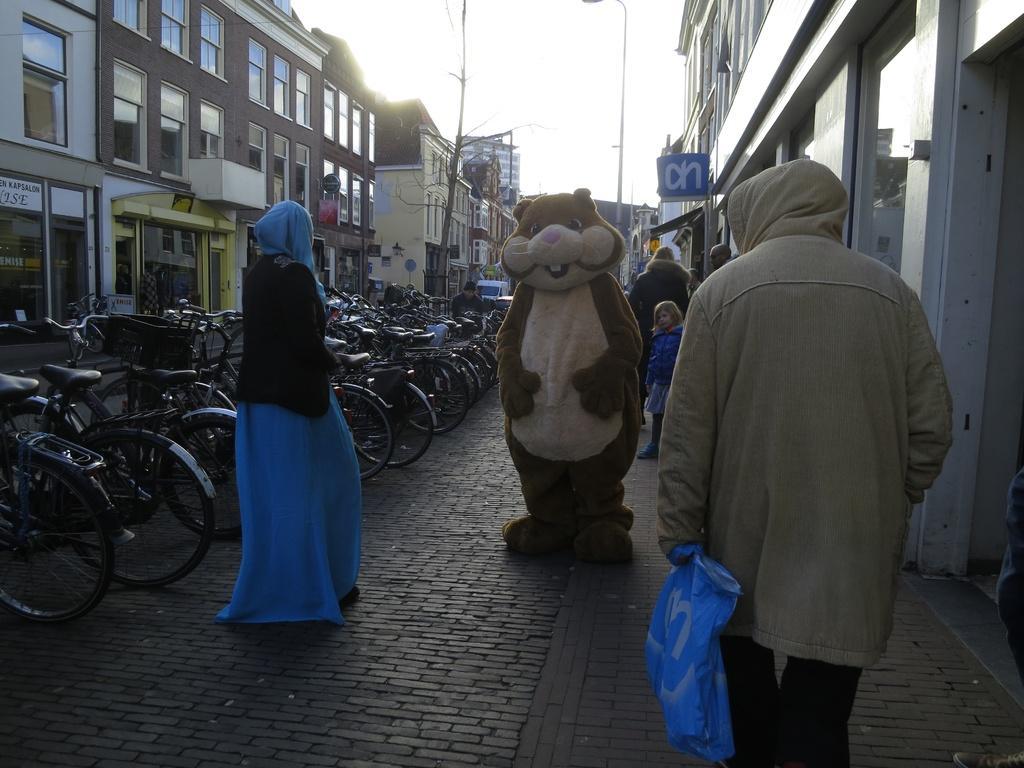Please provide a concise description of this image. In this image I can see few people are standing and here I can see a person in costume. I can also see number of bicycles, buildings, a pole, a street light, a blue colour board and here I can see something is written. 